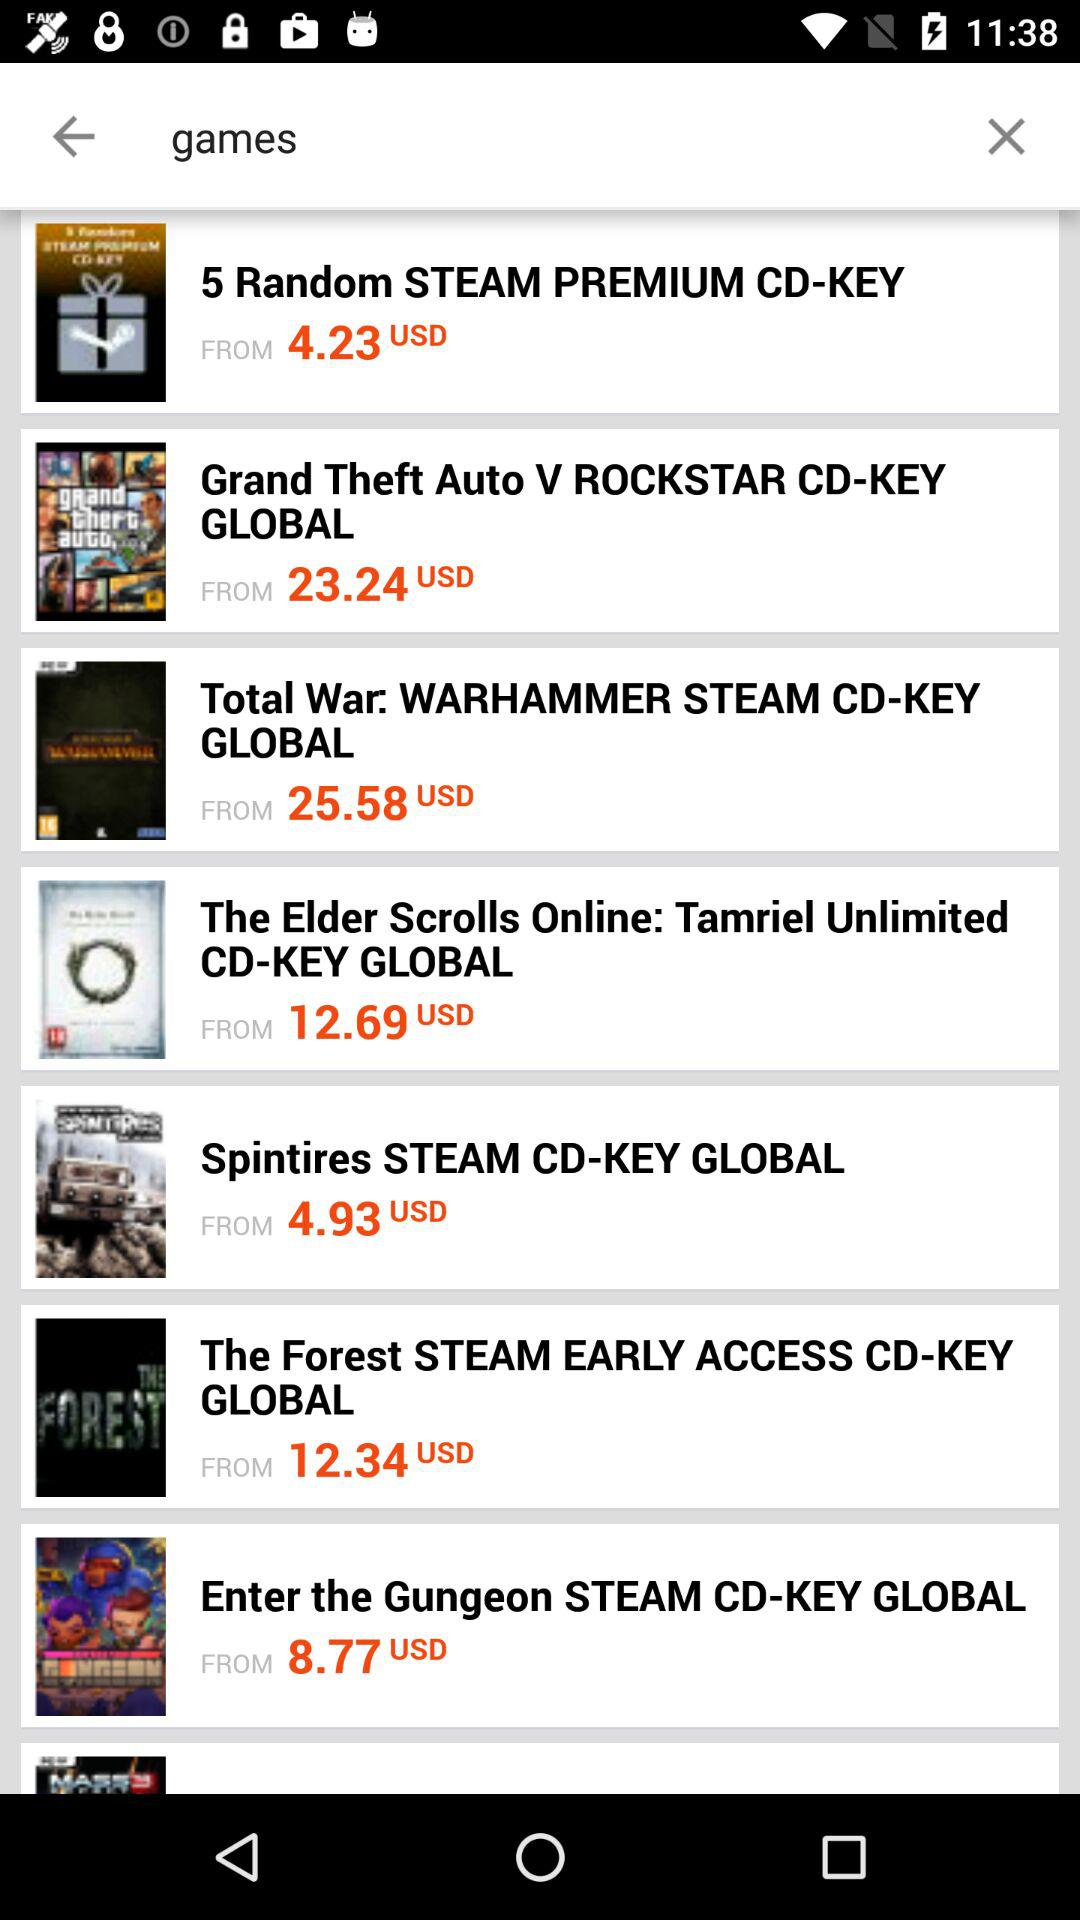Which CD key costs 4.23 USD? The CD key is "5 Random STEAM PREMIUM CD-KEY". 